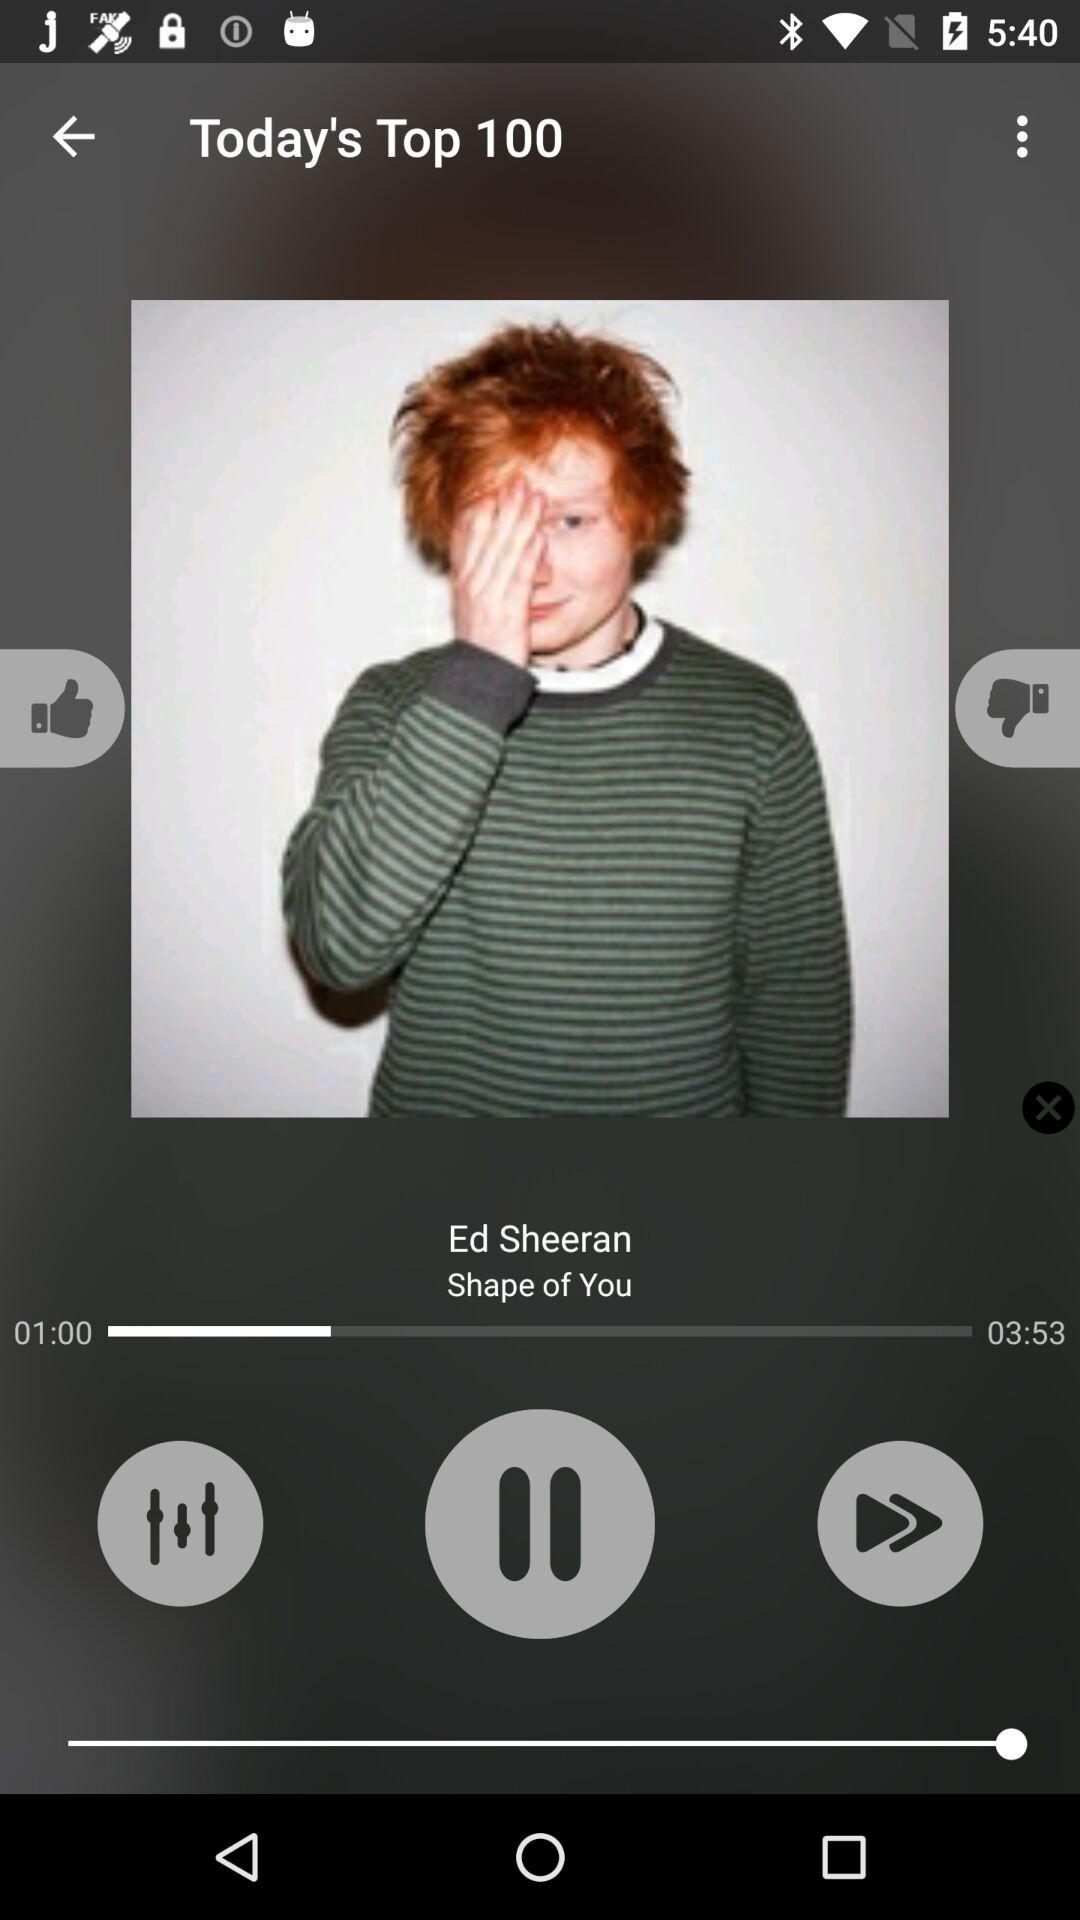Where does "Shape of You" rank in the top 100 list?
When the provided information is insufficient, respond with <no answer>. <no answer> 